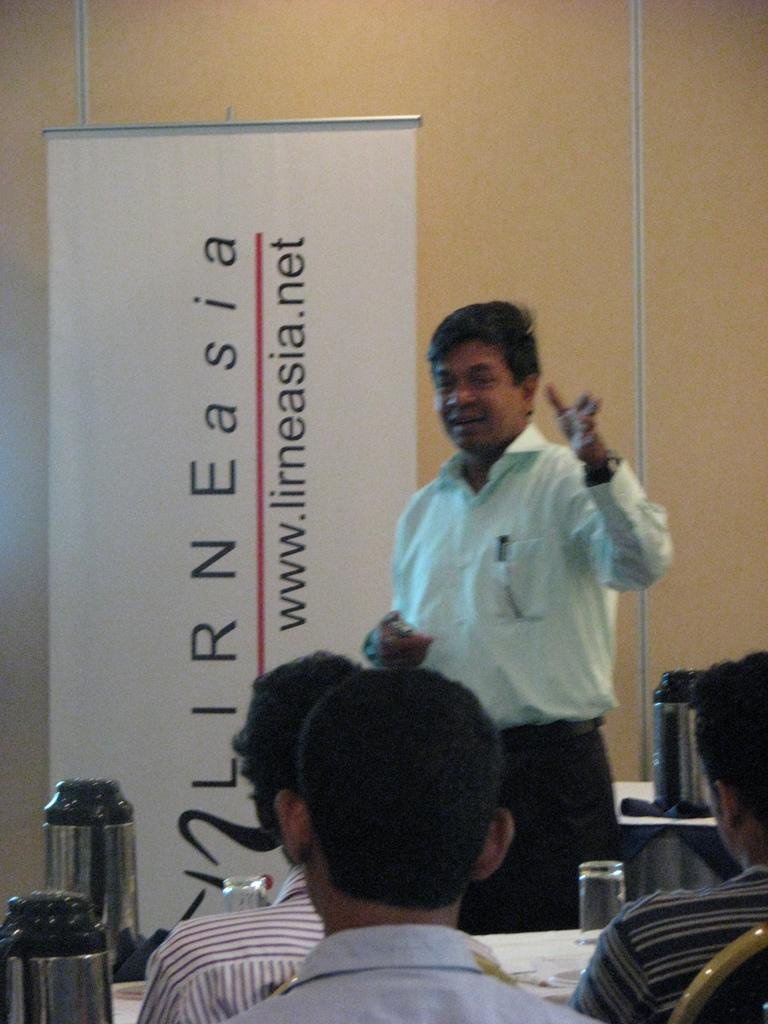<image>
Summarize the visual content of the image. Man giving a speech in front of a flag that says "lirneasia. 